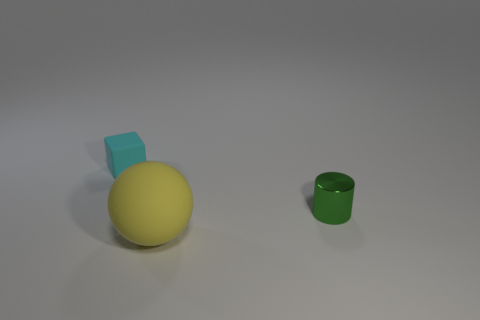There is a matte thing that is behind the shiny object; is it the same size as the object that is to the right of the big yellow matte ball?
Give a very brief answer. Yes. There is a matte object that is in front of the tiny thing that is to the left of the yellow rubber ball; what size is it?
Offer a very short reply. Large. What material is the thing that is both to the left of the cylinder and on the right side of the small matte object?
Offer a very short reply. Rubber. What is the color of the tiny metal cylinder?
Offer a very short reply. Green. Are there any other things that have the same material as the green cylinder?
Keep it short and to the point. No. There is a matte object that is behind the large yellow sphere; what shape is it?
Provide a succinct answer. Cube. There is a object left of the matte object in front of the cyan thing; is there a small green thing to the left of it?
Your response must be concise. No. Is there any other thing that is the same shape as the large yellow rubber thing?
Keep it short and to the point. No. Is there a large purple shiny cylinder?
Your answer should be very brief. No. Does the tiny object on the right side of the cyan rubber thing have the same material as the big yellow thing left of the small cylinder?
Offer a very short reply. No. 